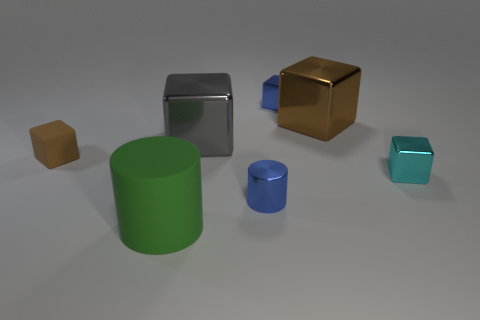There is a shiny thing that is the same color as the tiny rubber object; what shape is it?
Ensure brevity in your answer.  Cube. Does the small matte block have the same color as the shiny cylinder?
Provide a short and direct response. No. How many cylinders are either green things or brown objects?
Make the answer very short. 1. The object that is in front of the tiny blue metal cube and behind the gray cube is made of what material?
Keep it short and to the point. Metal. What number of large rubber things are behind the small cyan cube?
Offer a very short reply. 0. Do the tiny cube right of the brown metallic cube and the tiny blue cylinder to the left of the brown shiny object have the same material?
Keep it short and to the point. Yes. What number of objects are cubes on the left side of the big green matte cylinder or big yellow spheres?
Provide a short and direct response. 1. Is the number of small blue objects in front of the cyan cube less than the number of metal objects on the left side of the brown shiny object?
Ensure brevity in your answer.  Yes. How many other objects are the same size as the rubber cylinder?
Offer a terse response. 2. Does the large cylinder have the same material as the brown block on the right side of the large matte thing?
Offer a very short reply. No. 